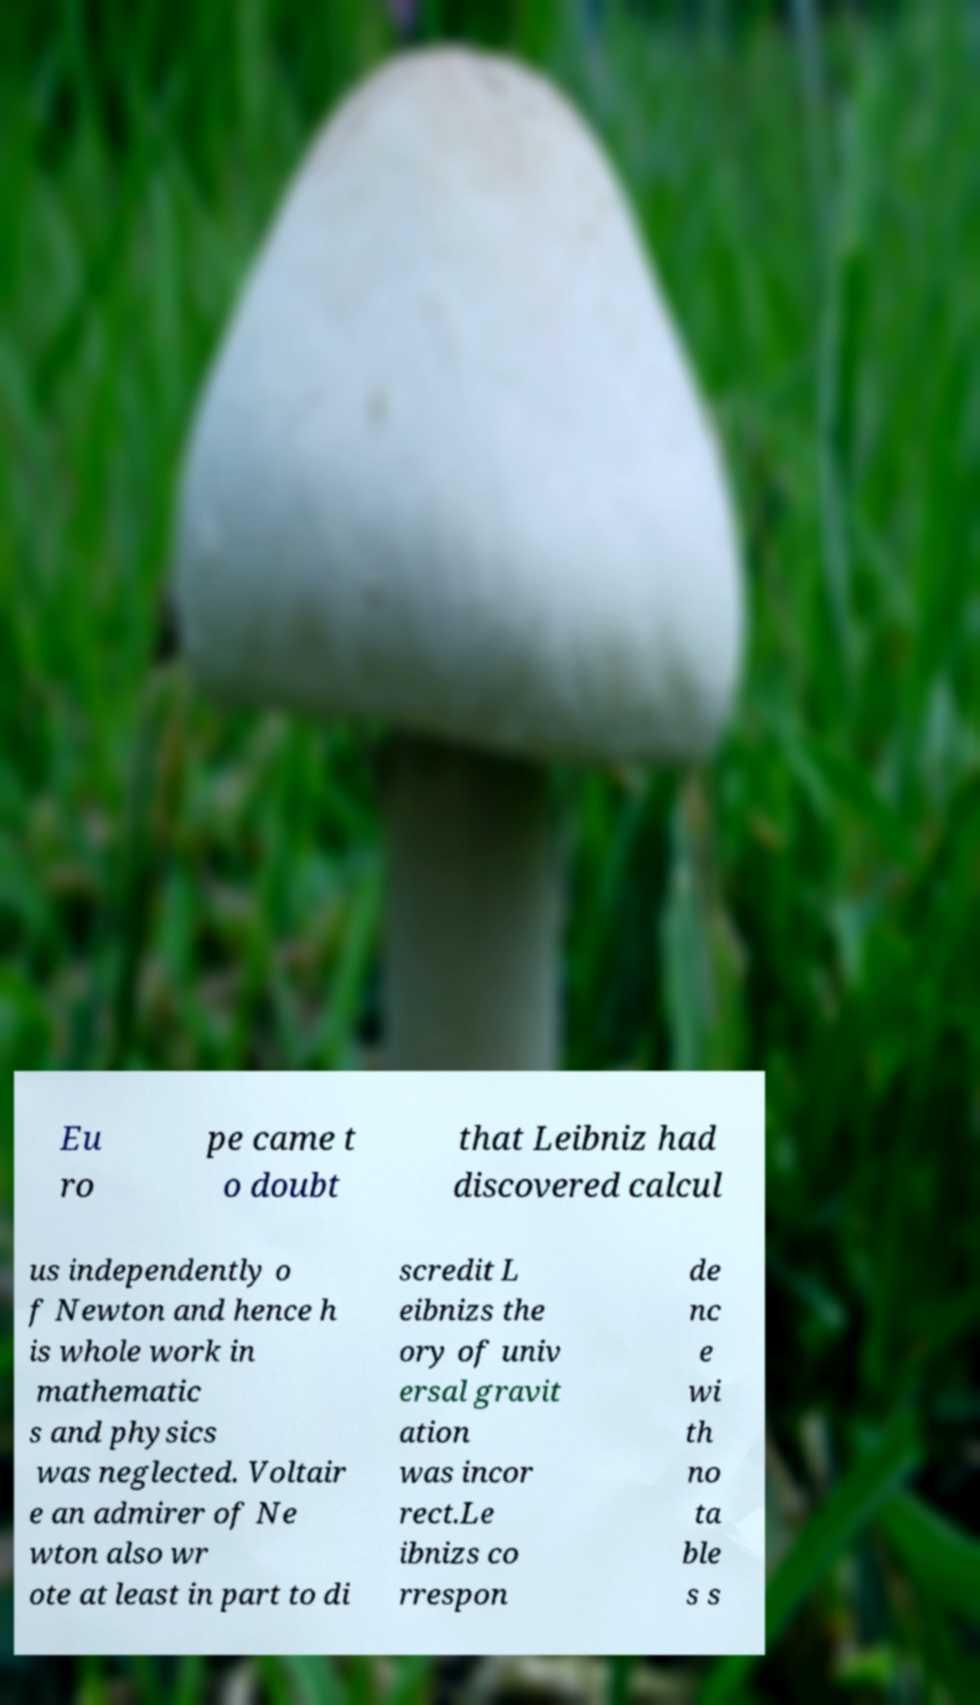Could you extract and type out the text from this image? Eu ro pe came t o doubt that Leibniz had discovered calcul us independently o f Newton and hence h is whole work in mathematic s and physics was neglected. Voltair e an admirer of Ne wton also wr ote at least in part to di scredit L eibnizs the ory of univ ersal gravit ation was incor rect.Le ibnizs co rrespon de nc e wi th no ta ble s s 